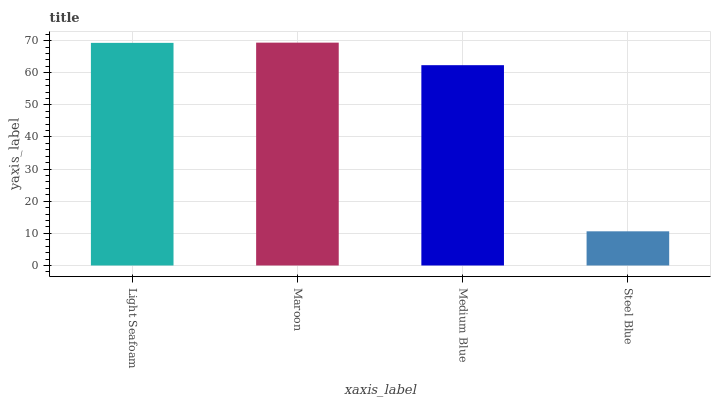Is Medium Blue the minimum?
Answer yes or no. No. Is Medium Blue the maximum?
Answer yes or no. No. Is Maroon greater than Medium Blue?
Answer yes or no. Yes. Is Medium Blue less than Maroon?
Answer yes or no. Yes. Is Medium Blue greater than Maroon?
Answer yes or no. No. Is Maroon less than Medium Blue?
Answer yes or no. No. Is Light Seafoam the high median?
Answer yes or no. Yes. Is Medium Blue the low median?
Answer yes or no. Yes. Is Steel Blue the high median?
Answer yes or no. No. Is Steel Blue the low median?
Answer yes or no. No. 